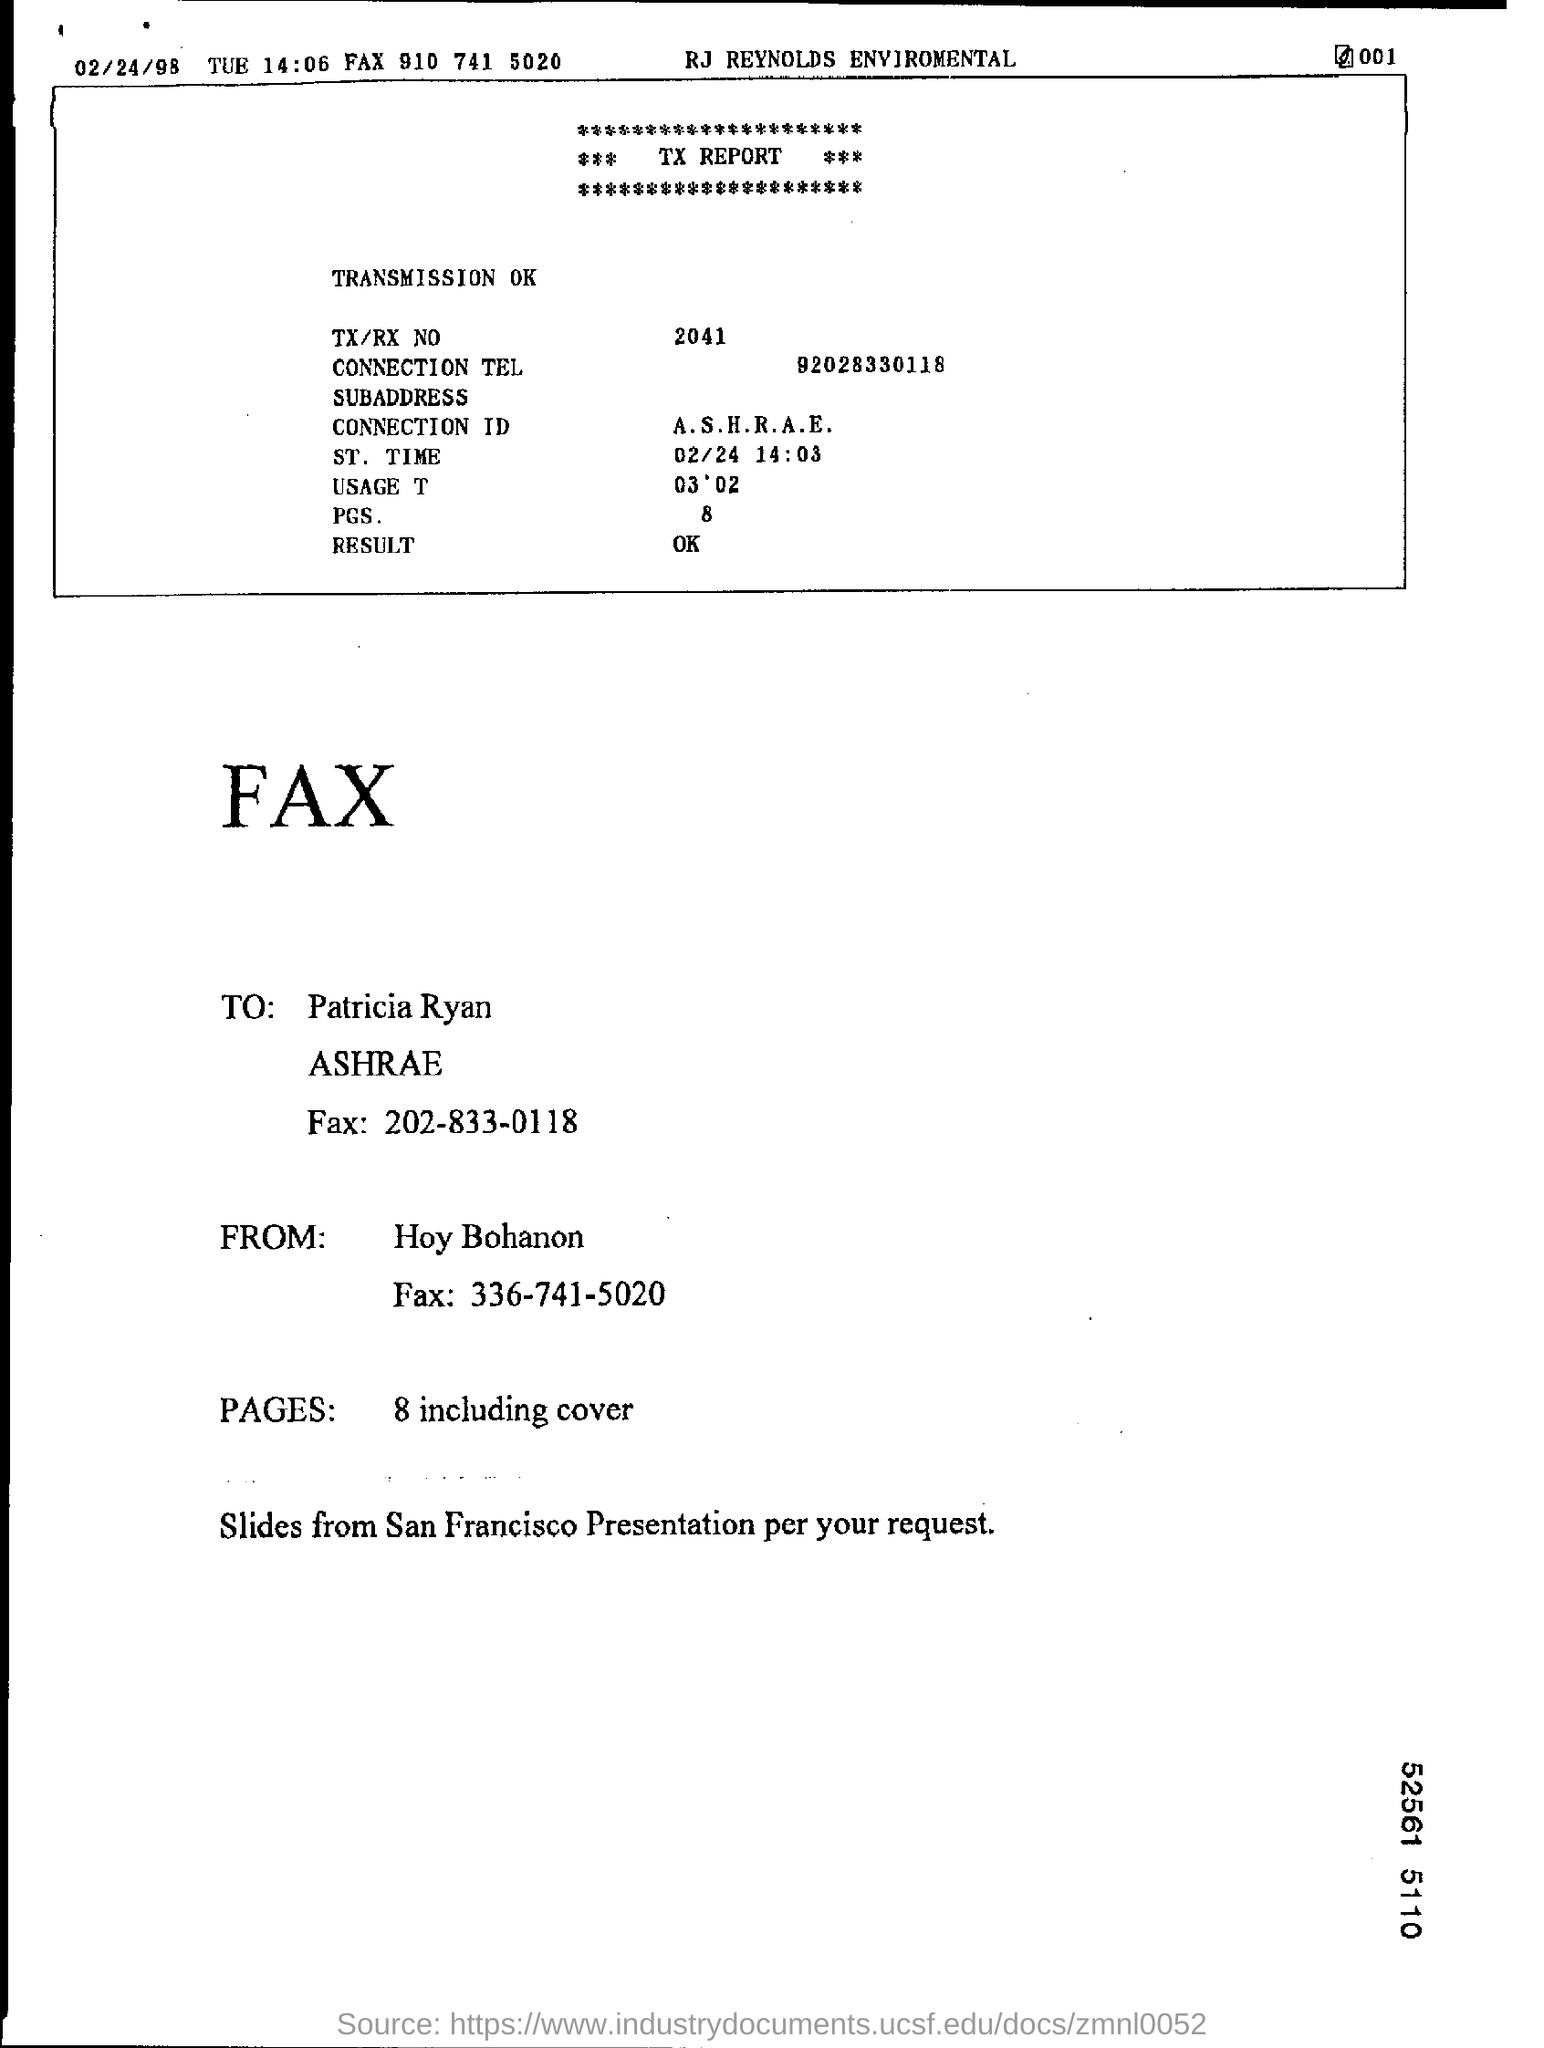What is the ST. Time?
Provide a short and direct response. 02/24 14:03. What is the Result?
Make the answer very short. OK. To Whom is this Fax addressed to?
Offer a terse response. Patricia Ryan. Who is this Fax from?
Keep it short and to the point. Hoy Bohanon. What is the TX/RX No.?
Your answer should be very brief. 2041. What is the Connection Tel?
Offer a terse response. 92028330118. 